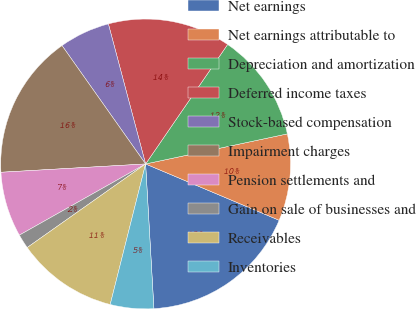Convert chart. <chart><loc_0><loc_0><loc_500><loc_500><pie_chart><fcel>Net earnings<fcel>Net earnings attributable to<fcel>Depreciation and amortization<fcel>Deferred income taxes<fcel>Stock-based compensation<fcel>Impairment charges<fcel>Pension settlements and<fcel>Gain on sale of businesses and<fcel>Receivables<fcel>Inventories<nl><fcel>17.74%<fcel>9.68%<fcel>12.1%<fcel>13.71%<fcel>5.65%<fcel>16.13%<fcel>7.26%<fcel>1.61%<fcel>11.29%<fcel>4.84%<nl></chart> 